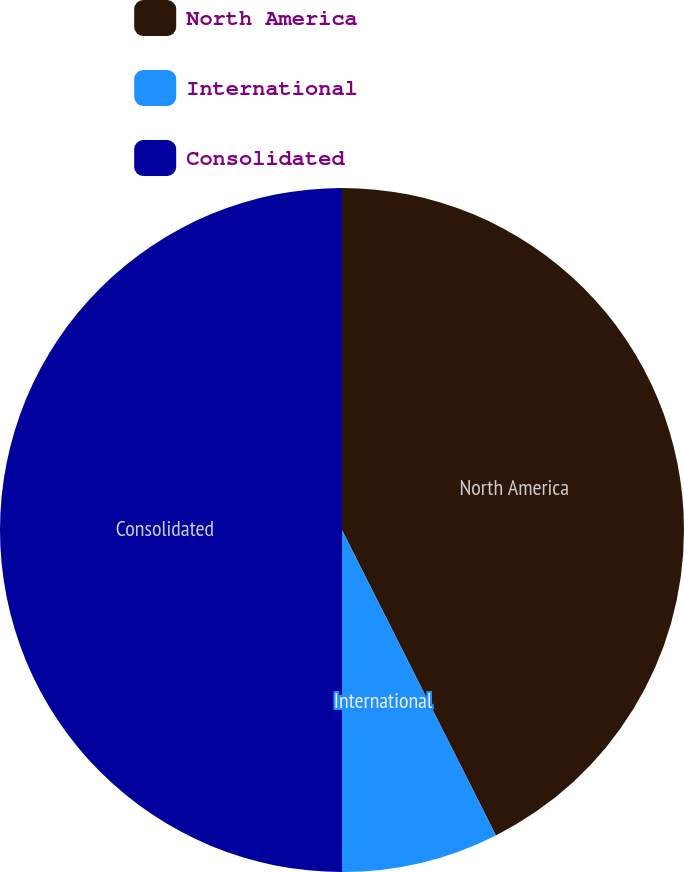Convert chart to OTSL. <chart><loc_0><loc_0><loc_500><loc_500><pie_chart><fcel>North America<fcel>International<fcel>Consolidated<nl><fcel>42.57%<fcel>7.43%<fcel>50.0%<nl></chart> 